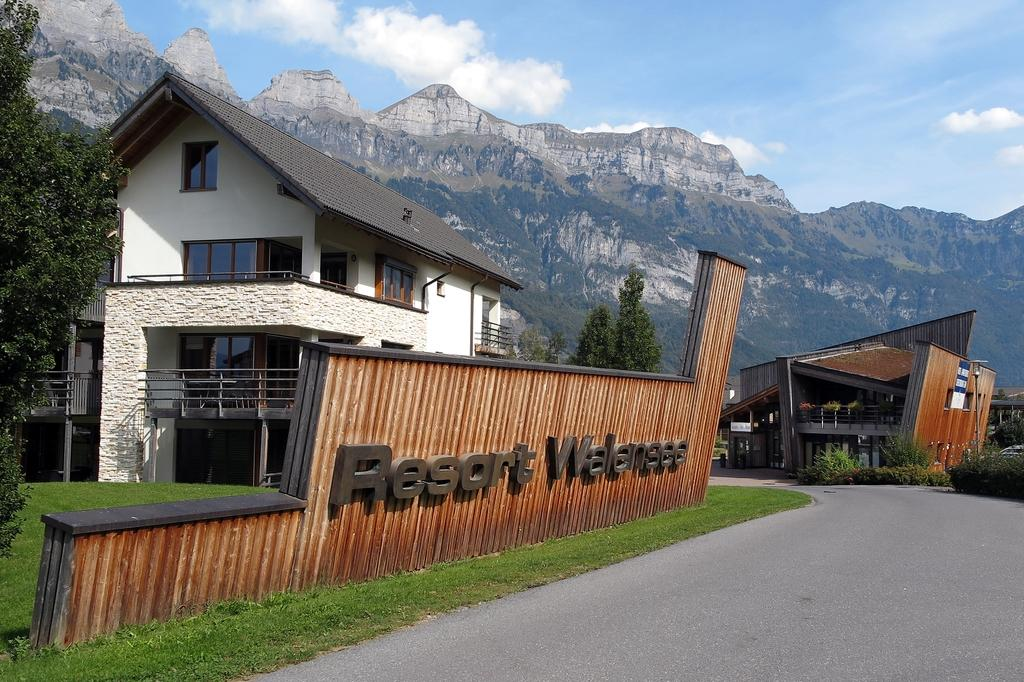What type of structures can be seen in the image? There are buildings in the image. What type of vegetation is present in the image? There are trees and grass in the image. What can be seen in the distance in the image? In the background of the image, there are hills. What is visible in the sky in the image? Clouds are visible in the background of the image. How do the giants interact with the buildings in the image? There are no giants present in the image; it features buildings, trees, grass, hills, and clouds. 